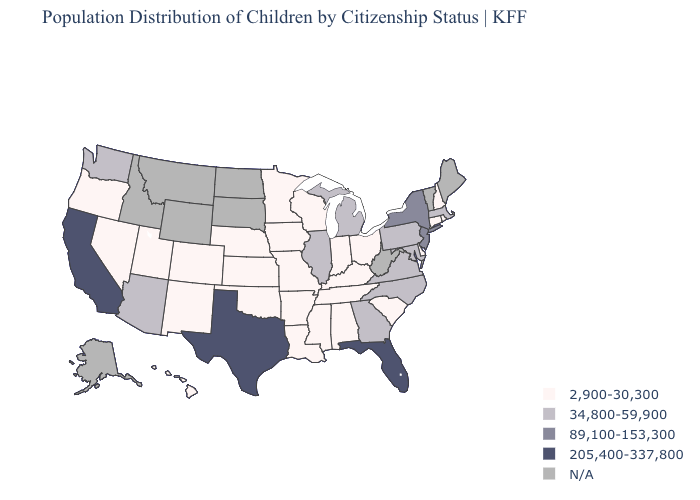Which states hav the highest value in the Northeast?
Short answer required. New Jersey, New York. Name the states that have a value in the range 205,400-337,800?
Be succinct. California, Florida, Texas. Does the map have missing data?
Be succinct. Yes. What is the value of Minnesota?
Be succinct. 2,900-30,300. How many symbols are there in the legend?
Give a very brief answer. 5. What is the value of Hawaii?
Answer briefly. 2,900-30,300. Does the map have missing data?
Write a very short answer. Yes. Which states hav the highest value in the West?
Keep it brief. California. What is the highest value in the West ?
Give a very brief answer. 205,400-337,800. Name the states that have a value in the range 34,800-59,900?
Answer briefly. Arizona, Georgia, Illinois, Maryland, Massachusetts, Michigan, North Carolina, Pennsylvania, Virginia, Washington. Among the states that border Ohio , does Indiana have the highest value?
Short answer required. No. Does California have the highest value in the USA?
Answer briefly. Yes. Is the legend a continuous bar?
Answer briefly. No. Among the states that border Arizona , which have the highest value?
Concise answer only. California. 